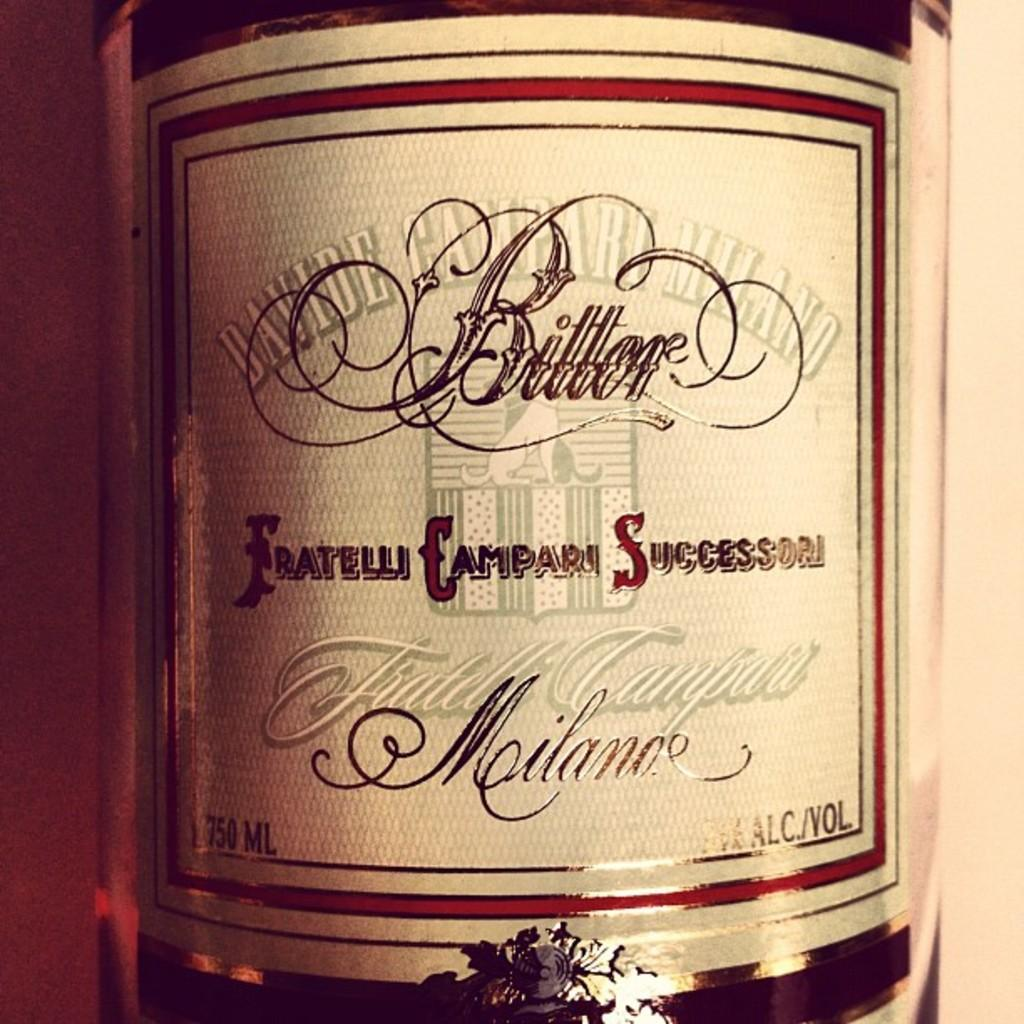<image>
Describe the image concisely. The amount of fluid in the container is 750ML 